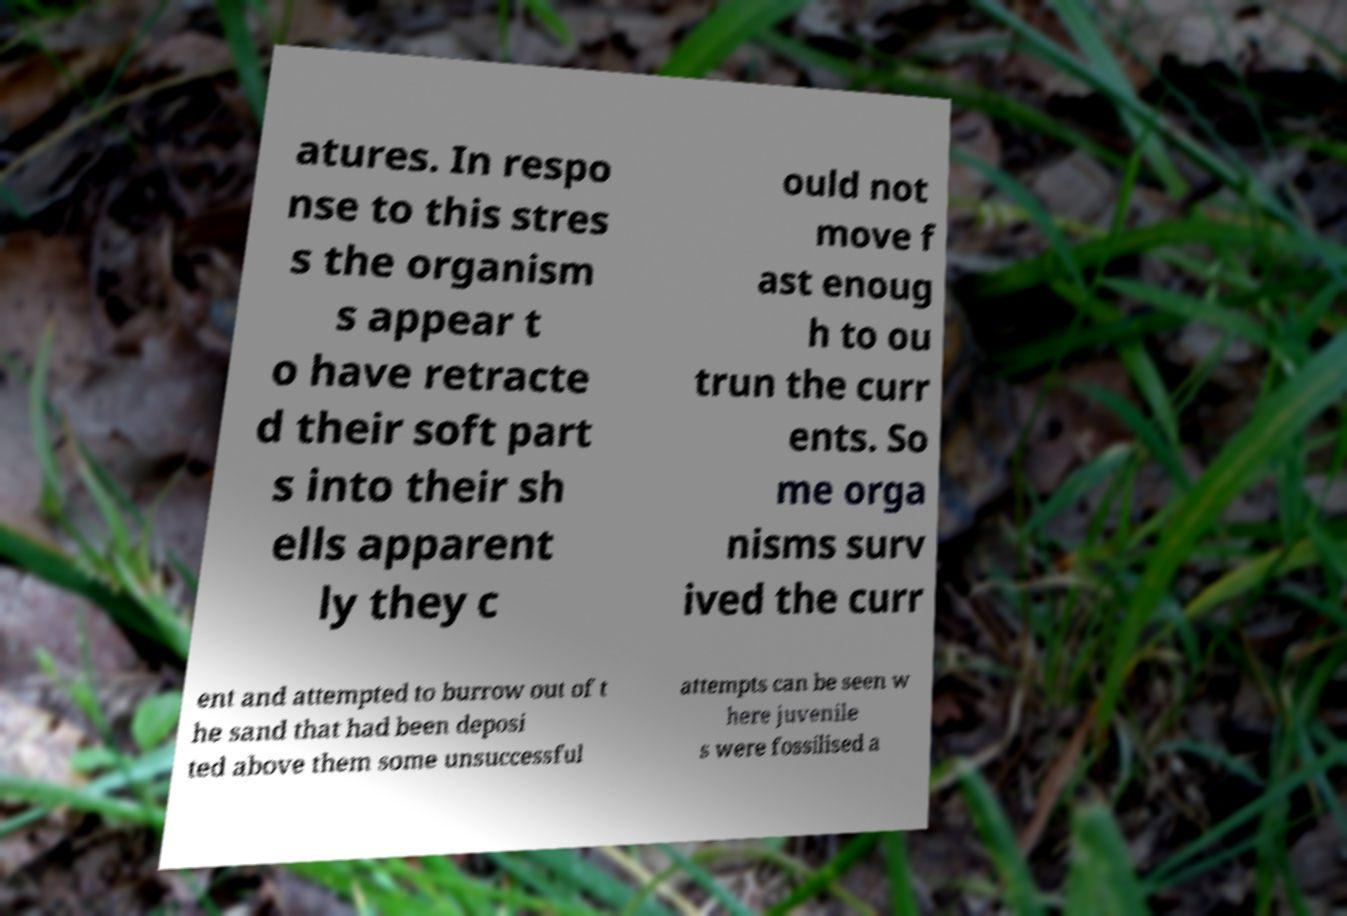Can you accurately transcribe the text from the provided image for me? atures. In respo nse to this stres s the organism s appear t o have retracte d their soft part s into their sh ells apparent ly they c ould not move f ast enoug h to ou trun the curr ents. So me orga nisms surv ived the curr ent and attempted to burrow out of t he sand that had been deposi ted above them some unsuccessful attempts can be seen w here juvenile s were fossilised a 